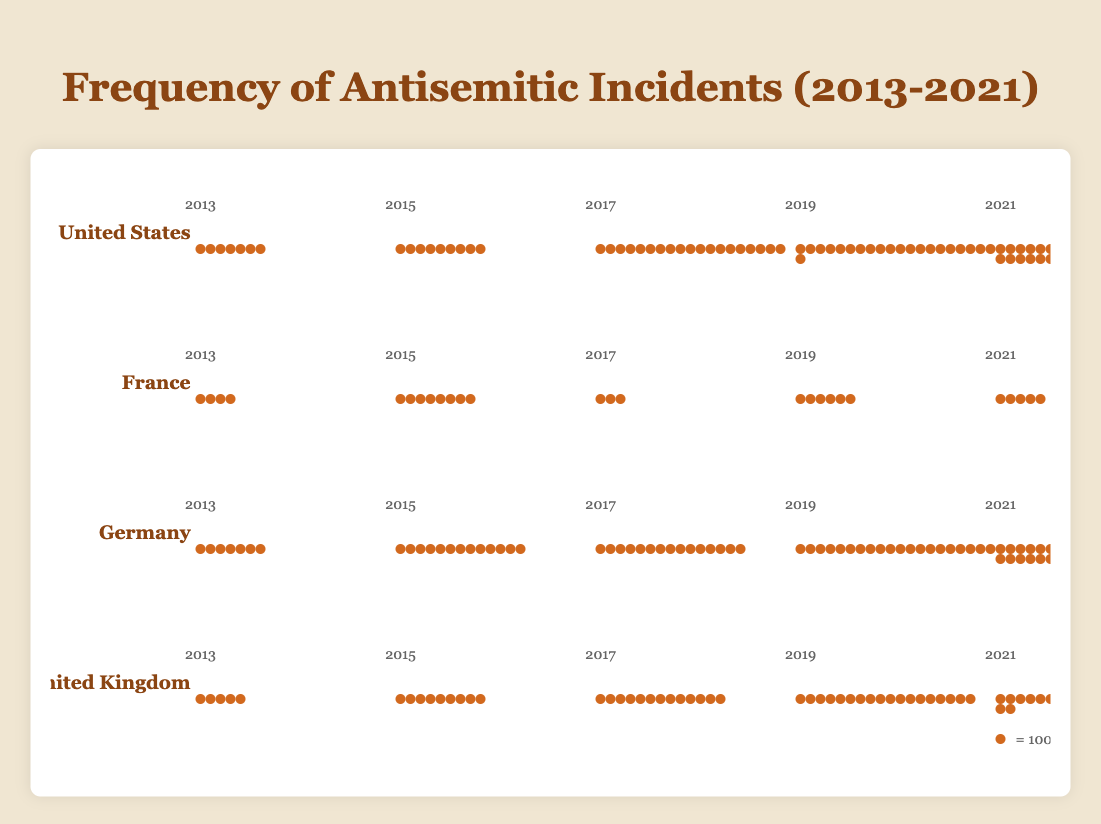What year saw the highest number of antisemitic incidents in the United States? Look for the year with the highest count within the United States section. The count for 2021 is the highest with 2717 incidents.
Answer: 2021 How many total antisemitic incidents were reported in France across 2013, 2015, and 2017? Sum the counts for the years 2013 (423), 2015 (808), and 2017 (311). The total is 423 + 808 + 311 = 1542.
Answer: 1542 Which country had the least number of antisemitic incidents reported in 2017? Compare the counts of incidents for each country in 2017. France had the least with 311 incidents.
Answer: France What is the average number of incidents reported in Germany over the years provided? Sum the counts for all the years and divide by the number of years: (788 + 1366 + 1504 + 2032 + 3028) / 5 = 8718 / 5 = 1743.6.
Answer: 1743.6 Is the trend of reported incidents in the United Kingdom increasing or decreasing over the years provided? Observe the counts in the United Kingdom over the years: 535 (2013), 924 (2015), 1382 (2017), 1813 (2019), and 2255 (2021). All values are increasing.
Answer: Increasing In which year did the United States experience a sharp increase in antisemitic incidents compared to the previous data point? Compare the counts year-over-year and identify the largest jump. The jump between 2015 (942) and 2017 (1986) is significant compared to other years.
Answer: 2017 What are the total reported incidents across all countries in 2021? Sum the counts for each country in 2021: 2717 (US) + 589 (France) + 3028 (Germany) + 2255 (UK) = 8589.
Answer: 8589 How many more incidents were reported in Germany in 2021 compared to 2013? Subtract the incidents reported in 2013 from those in 2021: 3028 (2021) - 788 (2013) = 2240.
Answer: 2240 Which country had the highest increase in reported incidents from 2019 to 2021? Calculate the difference for each country between 2019 and 2021, and identify the highest value. Germany's increase from 2032 to 3028 (996) is the highest.
Answer: Germany How many incidents per year would make an average if the number of reported incidents in France from 2013 to 2021 were evenly distributed? Sum the incidents from 2013 to 2021 and divide by the number of years: (423 + 808 + 311 + 687 + 589) / 5 = 2818 / 5 = 563.6.
Answer: 563.6 